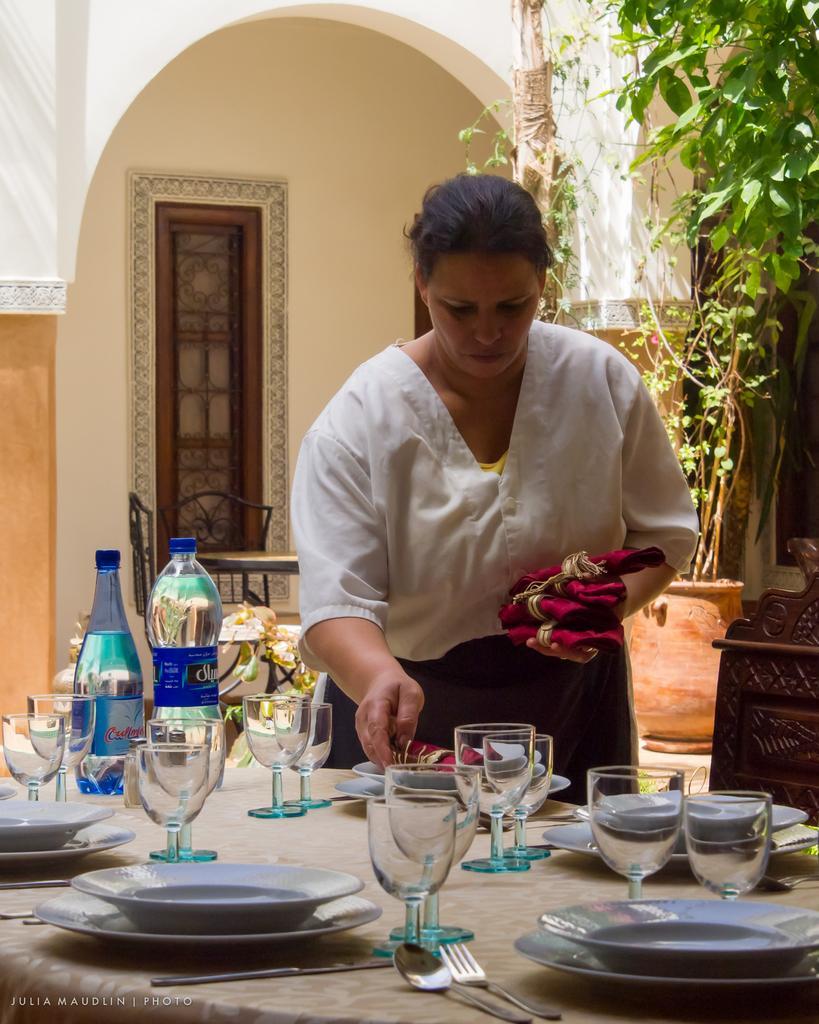Please provide a concise description of this image. In this image I see a woman who is holding the napkins, I also there is a table in front and there are 2 water bottles, many glasses and many plates on it. In the background I see 2 chairs, plants and the window. 